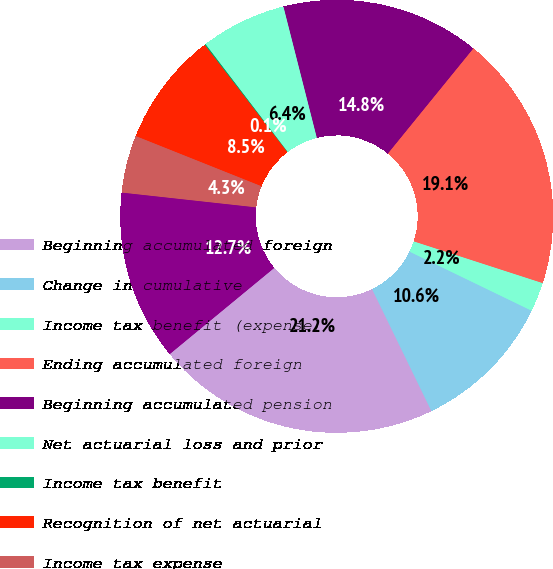<chart> <loc_0><loc_0><loc_500><loc_500><pie_chart><fcel>Beginning accumulated foreign<fcel>Change in cumulative<fcel>Income tax benefit (expense)<fcel>Ending accumulated foreign<fcel>Beginning accumulated pension<fcel>Net actuarial loss and prior<fcel>Income tax benefit<fcel>Recognition of net actuarial<fcel>Income tax expense<fcel>Ending accumulated pension and<nl><fcel>21.23%<fcel>10.62%<fcel>2.19%<fcel>19.12%<fcel>14.83%<fcel>6.4%<fcel>0.08%<fcel>8.51%<fcel>4.3%<fcel>12.72%<nl></chart> 